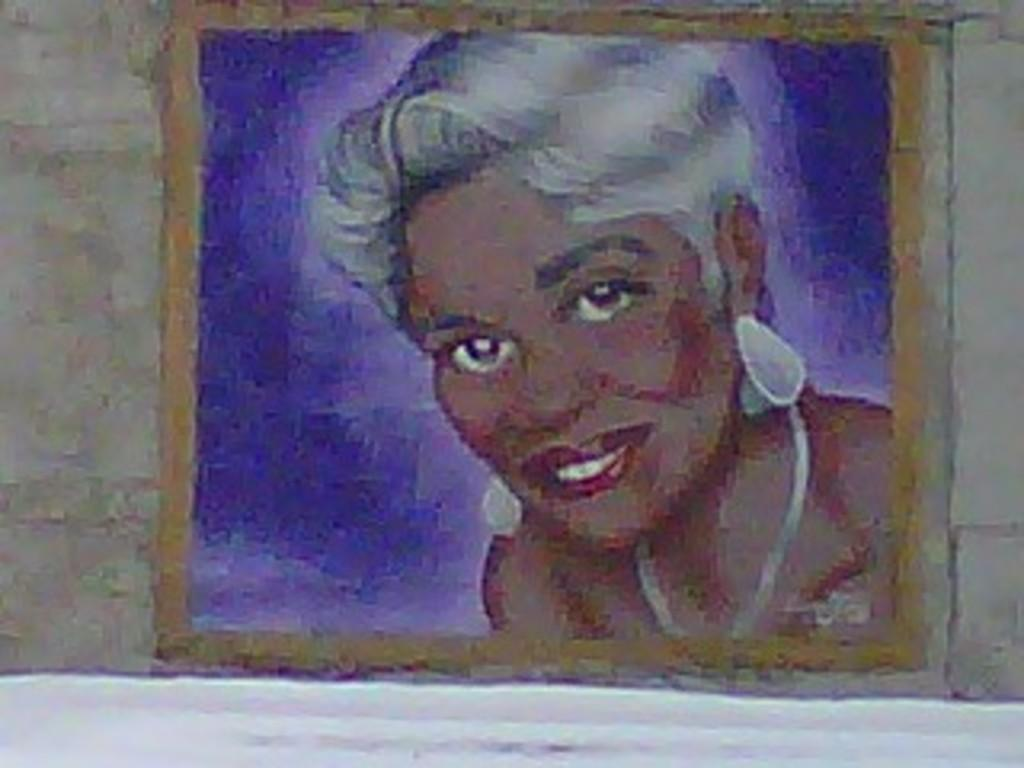What is present on the wall in the image? There is a painting of a lady on the wall. Can you describe the painting in more detail? Unfortunately, the provided facts do not give any additional details about the painting. What is the primary color used in the painting? The provided facts do not mention the primary color used in the painting. How many clover leaves are depicted in the painting? There is no mention of clover leaves in the image or the painting, so it is not possible to answer this question. 